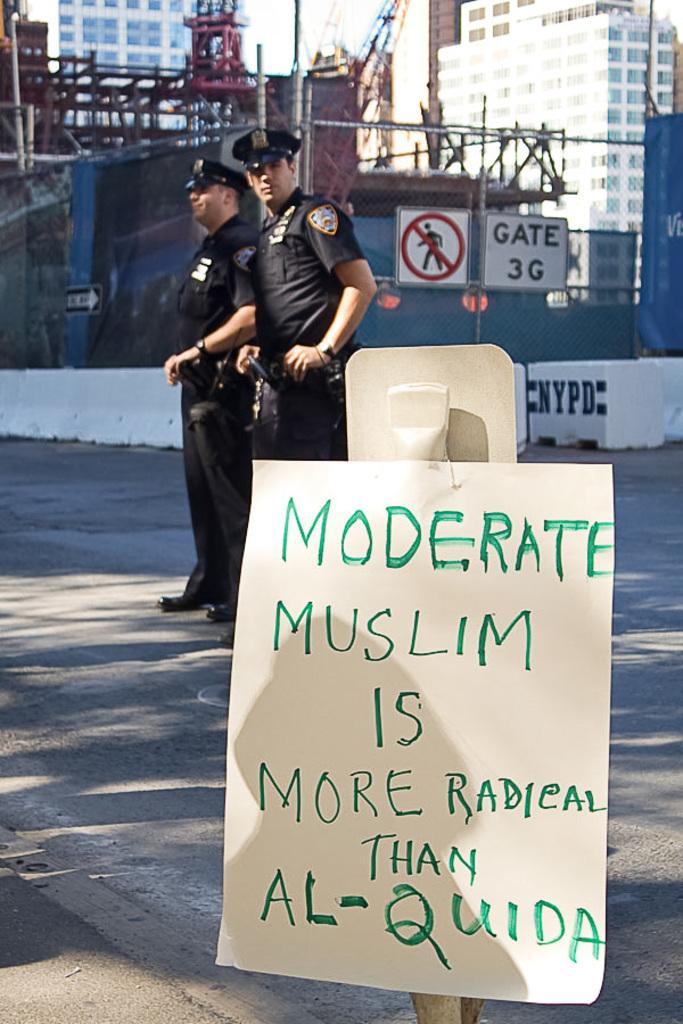Can you describe this image briefly? In this image there are two officers standing on the road. At the bottom there is a placard. In the background there is construction of the building. On the right side there are two caution boards on the road. 